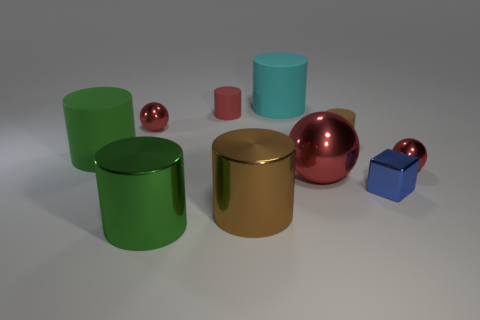There is a tiny matte thing that is right of the large red shiny ball; what is its shape?
Keep it short and to the point. Cylinder. There is a big rubber object that is on the right side of the green shiny object; is there a cylinder in front of it?
Provide a succinct answer. Yes. The large cylinder that is to the right of the green metal cylinder and behind the large brown shiny thing is what color?
Your answer should be compact. Cyan. There is a green thing that is behind the small red metal object that is in front of the small brown object; are there any big objects in front of it?
Make the answer very short. Yes. What is the size of the red matte thing that is the same shape as the large green metallic thing?
Provide a succinct answer. Small. Are any red things visible?
Offer a terse response. Yes. There is a big ball; does it have the same color as the small thing that is to the left of the tiny red cylinder?
Offer a very short reply. Yes. There is a cylinder that is to the left of the big shiny object left of the big brown metallic cylinder left of the shiny block; what size is it?
Ensure brevity in your answer.  Large. How many tiny matte things have the same color as the block?
Give a very brief answer. 0. What number of things are tiny matte balls or balls that are in front of the big cyan cylinder?
Offer a very short reply. 3. 